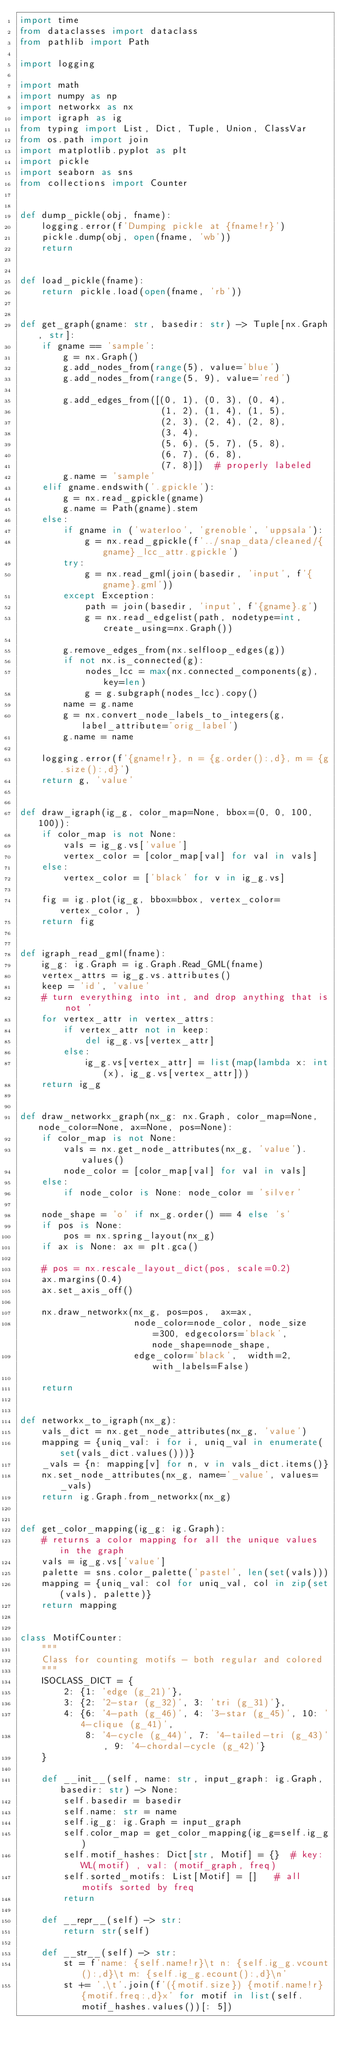<code> <loc_0><loc_0><loc_500><loc_500><_Python_>import time
from dataclasses import dataclass
from pathlib import Path

import logging

import math
import numpy as np
import networkx as nx
import igraph as ig
from typing import List, Dict, Tuple, Union, ClassVar
from os.path import join
import matplotlib.pyplot as plt
import pickle
import seaborn as sns
from collections import Counter


def dump_pickle(obj, fname):
    logging.error(f'Dumping pickle at {fname!r}')
    pickle.dump(obj, open(fname, 'wb'))
    return


def load_pickle(fname):
    return pickle.load(open(fname, 'rb'))


def get_graph(gname: str, basedir: str) -> Tuple[nx.Graph, str]:
    if gname == 'sample':
        g = nx.Graph()
        g.add_nodes_from(range(5), value='blue')
        g.add_nodes_from(range(5, 9), value='red')

        g.add_edges_from([(0, 1), (0, 3), (0, 4),
                          (1, 2), (1, 4), (1, 5),
                          (2, 3), (2, 4), (2, 8),
                          (3, 4),
                          (5, 6), (5, 7), (5, 8),
                          (6, 7), (6, 8),
                          (7, 8)])  # properly labeled
        g.name = 'sample'
    elif gname.endswith('.gpickle'):
        g = nx.read_gpickle(gname)
        g.name = Path(gname).stem
    else:
        if gname in ('waterloo', 'grenoble', 'uppsala'):
            g = nx.read_gpickle(f'../snap_data/cleaned/{gname}_lcc_attr.gpickle')
        try:
            g = nx.read_gml(join(basedir, 'input', f'{gname}.gml'))
        except Exception:
            path = join(basedir, 'input', f'{gname}.g')
            g = nx.read_edgelist(path, nodetype=int, create_using=nx.Graph())

        g.remove_edges_from(nx.selfloop_edges(g))
        if not nx.is_connected(g):
            nodes_lcc = max(nx.connected_components(g), key=len)
            g = g.subgraph(nodes_lcc).copy()
        name = g.name
        g = nx.convert_node_labels_to_integers(g, label_attribute='orig_label')
        g.name = name

    logging.error(f'{gname!r}, n = {g.order():,d}, m = {g.size():,d}')
    return g, 'value'


def draw_igraph(ig_g, color_map=None, bbox=(0, 0, 100, 100)):
    if color_map is not None:
        vals = ig_g.vs['value']
        vertex_color = [color_map[val] for val in vals]
    else:
        vertex_color = ['black' for v in ig_g.vs]

    fig = ig.plot(ig_g, bbox=bbox, vertex_color=vertex_color, )
    return fig


def igraph_read_gml(fname):
    ig_g: ig.Graph = ig.Graph.Read_GML(fname)
    vertex_attrs = ig_g.vs.attributes()
    keep = 'id', 'value'
    # turn everything into int, and drop anything that is not '
    for vertex_attr in vertex_attrs:
        if vertex_attr not in keep:
            del ig_g.vs[vertex_attr]
        else:
            ig_g.vs[vertex_attr] = list(map(lambda x: int(x), ig_g.vs[vertex_attr]))
    return ig_g


def draw_networkx_graph(nx_g: nx.Graph, color_map=None, node_color=None, ax=None, pos=None):
    if color_map is not None:
        vals = nx.get_node_attributes(nx_g, 'value').values()
        node_color = [color_map[val] for val in vals]
    else:
        if node_color is None: node_color = 'silver'

    node_shape = 'o' if nx_g.order() == 4 else 's'
    if pos is None:
        pos = nx.spring_layout(nx_g)
    if ax is None: ax = plt.gca()

    # pos = nx.rescale_layout_dict(pos, scale=0.2)
    ax.margins(0.4)
    ax.set_axis_off()

    nx.draw_networkx(nx_g, pos=pos,  ax=ax,
                     node_color=node_color, node_size=300, edgecolors='black', node_shape=node_shape,
                     edge_color='black',  width=2, with_labels=False)

    return


def networkx_to_igraph(nx_g):
    vals_dict = nx.get_node_attributes(nx_g, 'value')
    mapping = {uniq_val: i for i, uniq_val in enumerate(set(vals_dict.values()))}
    _vals = {n: mapping[v] for n, v in vals_dict.items()}
    nx.set_node_attributes(nx_g, name='_value', values=_vals)
    return ig.Graph.from_networkx(nx_g)


def get_color_mapping(ig_g: ig.Graph):
    # returns a color mapping for all the unique values in the graph
    vals = ig_g.vs['value']
    palette = sns.color_palette('pastel', len(set(vals)))
    mapping = {uniq_val: col for uniq_val, col in zip(set(vals), palette)}
    return mapping


class MotifCounter:
    """
    Class for counting motifs - both regular and colored
    """
    ISOCLASS_DICT = {
        2: {1: 'edge (g_21)'},
        3: {2: '2-star (g_32)', 3: 'tri (g_31)'},
        4: {6: '4-path (g_46)', 4: '3-star (g_45)', 10: '4-clique (g_41)',
            8: '4-cycle (g_44)', 7: '4-tailed-tri (g_43)', 9: '4-chordal-cycle (g_42)'}
    }

    def __init__(self, name: str, input_graph: ig.Graph, basedir: str) -> None:
        self.basedir = basedir
        self.name: str = name
        self.ig_g: ig.Graph = input_graph
        self.color_map = get_color_mapping(ig_g=self.ig_g)
        self.motif_hashes: Dict[str, Motif] = {}  # key: WL(motif) , val: (motif_graph, freq)
        self.sorted_motifs: List[Motif] = []   # all motifs sorted by freq
        return

    def __repr__(self) -> str:
        return str(self)

    def __str__(self) -> str:
        st = f'name: {self.name!r}\t n: {self.ig_g.vcount():,d}\t m: {self.ig_g.ecount():,d}\n'
        st += ',\t'.join(f'({motif.size}) {motif.name!r} {motif.freq:,d}x' for motif in list(self.motif_hashes.values())[: 5])</code> 